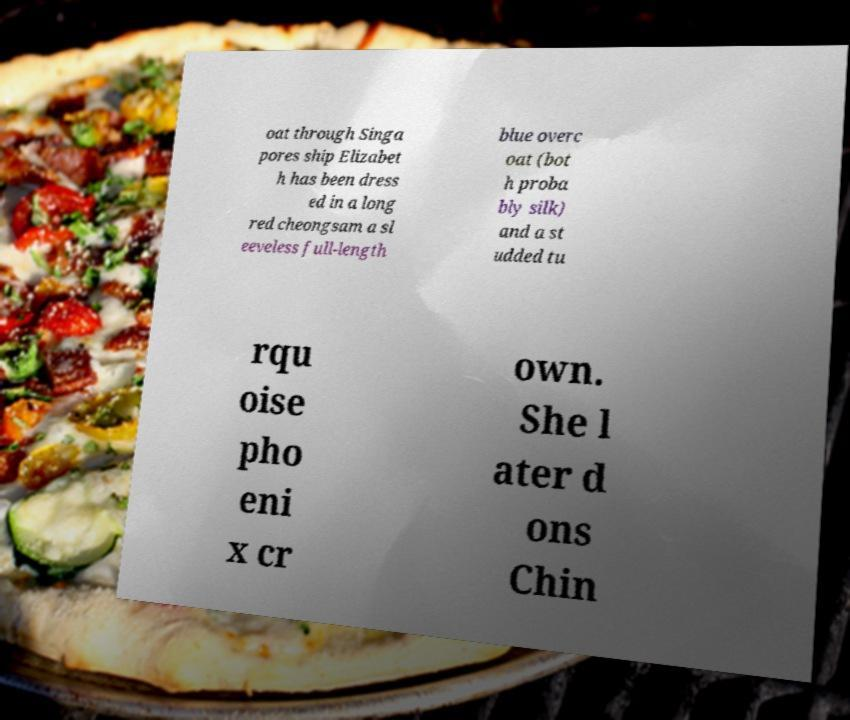Please identify and transcribe the text found in this image. oat through Singa pores ship Elizabet h has been dress ed in a long red cheongsam a sl eeveless full-length blue overc oat (bot h proba bly silk) and a st udded tu rqu oise pho eni x cr own. She l ater d ons Chin 